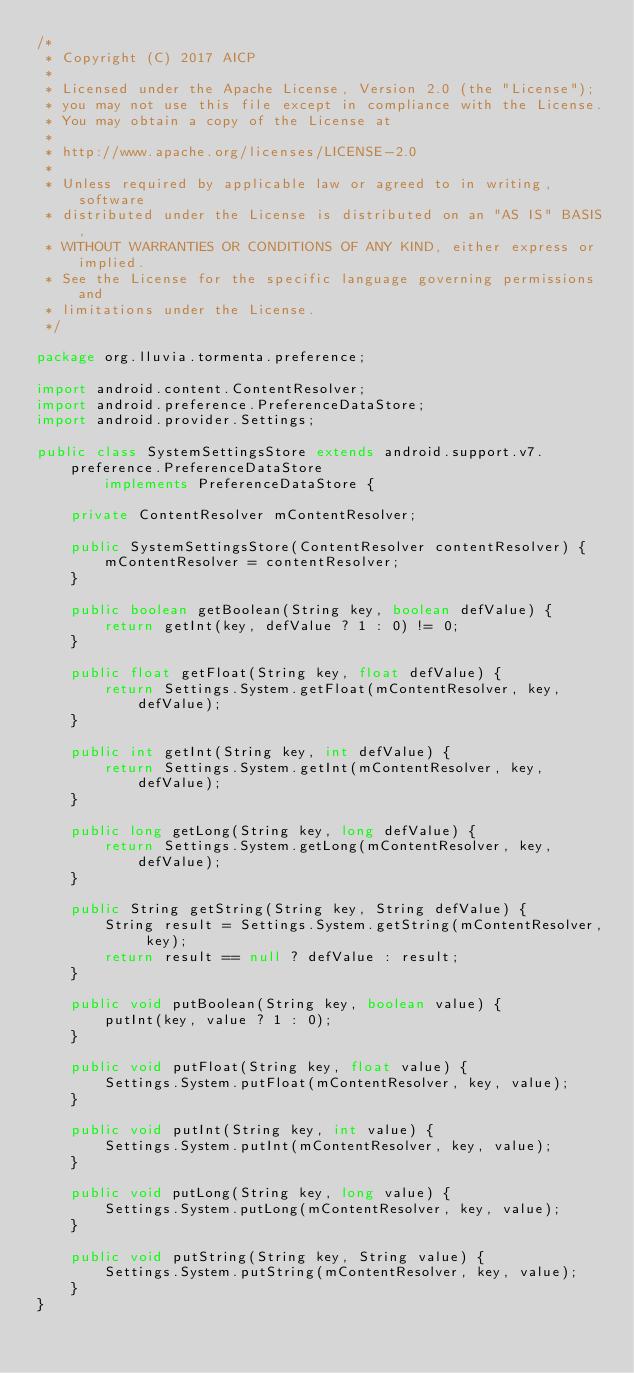<code> <loc_0><loc_0><loc_500><loc_500><_Java_>/*
 * Copyright (C) 2017 AICP
 *
 * Licensed under the Apache License, Version 2.0 (the "License");
 * you may not use this file except in compliance with the License.
 * You may obtain a copy of the License at
 *
 * http://www.apache.org/licenses/LICENSE-2.0
 *
 * Unless required by applicable law or agreed to in writing, software
 * distributed under the License is distributed on an "AS IS" BASIS,
 * WITHOUT WARRANTIES OR CONDITIONS OF ANY KIND, either express or implied.
 * See the License for the specific language governing permissions and
 * limitations under the License.
 */

package org.lluvia.tormenta.preference;

import android.content.ContentResolver;
import android.preference.PreferenceDataStore;
import android.provider.Settings;

public class SystemSettingsStore extends android.support.v7.preference.PreferenceDataStore
        implements PreferenceDataStore {

    private ContentResolver mContentResolver;

    public SystemSettingsStore(ContentResolver contentResolver) {
        mContentResolver = contentResolver;
    }

    public boolean getBoolean(String key, boolean defValue) {
        return getInt(key, defValue ? 1 : 0) != 0;
    }

    public float getFloat(String key, float defValue) {
        return Settings.System.getFloat(mContentResolver, key, defValue);
    }

    public int getInt(String key, int defValue) {
        return Settings.System.getInt(mContentResolver, key, defValue);
    }

    public long getLong(String key, long defValue) {
        return Settings.System.getLong(mContentResolver, key, defValue);
    }

    public String getString(String key, String defValue) {
        String result = Settings.System.getString(mContentResolver, key);
        return result == null ? defValue : result;
    }

    public void putBoolean(String key, boolean value) {
        putInt(key, value ? 1 : 0);
    }

    public void putFloat(String key, float value) {
        Settings.System.putFloat(mContentResolver, key, value);
    }

    public void putInt(String key, int value) {
        Settings.System.putInt(mContentResolver, key, value);
    }

    public void putLong(String key, long value) {
        Settings.System.putLong(mContentResolver, key, value);
    }

    public void putString(String key, String value) {
        Settings.System.putString(mContentResolver, key, value);
    }
}
</code> 